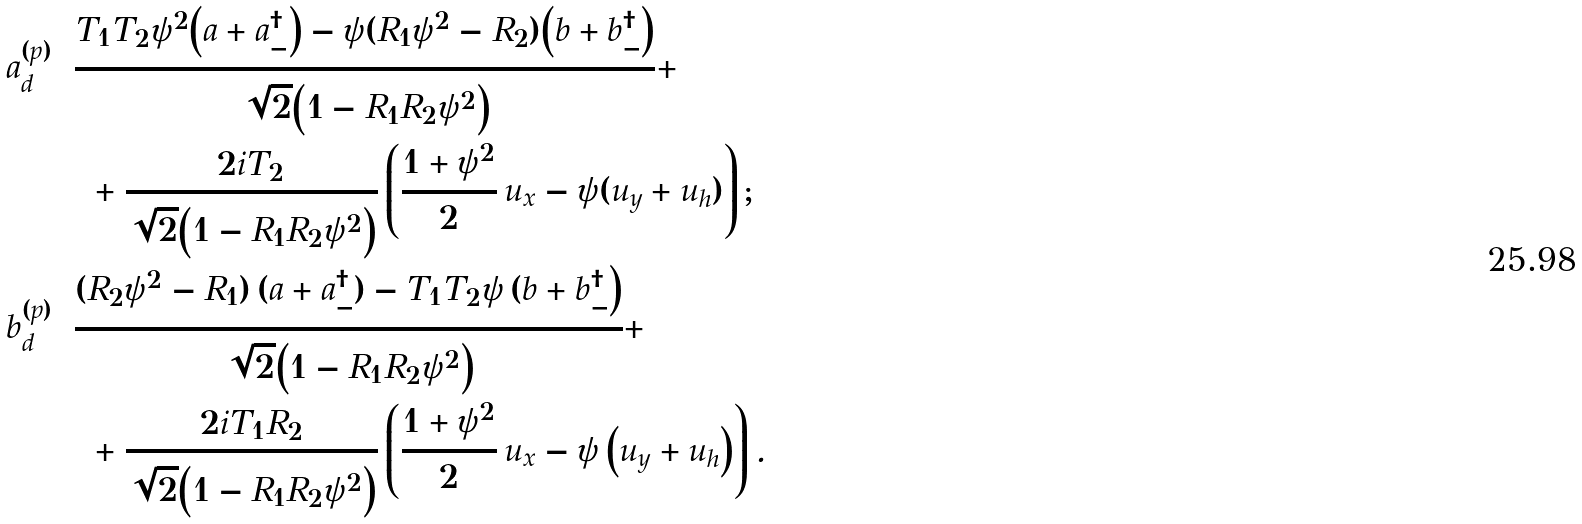Convert formula to latex. <formula><loc_0><loc_0><loc_500><loc_500>a _ { d } ^ { ( p ) } & = \frac { T _ { 1 } T _ { 2 } \psi ^ { 2 } \Big ( a + a ^ { \dag } _ { - } \Big ) - \psi ( R _ { 1 } \psi ^ { 2 } - R _ { 2 } ) \Big ( b + b _ { - } ^ { \dag } \Big ) } { \sqrt { 2 } \Big ( 1 - R _ { 1 } R _ { 2 } \psi ^ { 2 } \Big ) } + \\ & \quad + \frac { 2 i T _ { 2 } } { \sqrt { 2 } \Big ( 1 - R _ { 1 } R _ { 2 } \psi ^ { 2 } \Big ) } \left ( \frac { 1 + \psi ^ { 2 } } { 2 } \, u _ { x } - \psi ( u _ { y } + u _ { h } ) \right ) ; \\ b _ { d } ^ { ( p ) } & = \frac { ( R _ { 2 } \psi ^ { 2 } - R _ { 1 } ) \, ( a + a ^ { \dag } _ { - } ) - T _ { 1 } T _ { 2 } \psi \, ( b + b _ { - } ^ { \dag } \Big ) } { \sqrt { 2 } \Big ( 1 - R _ { 1 } R _ { 2 } \psi ^ { 2 } \Big ) } + \\ & \quad + \frac { 2 i T _ { 1 } R _ { 2 } } { \sqrt { 2 } \Big ( 1 - R _ { 1 } R _ { 2 } \psi ^ { 2 } \Big ) } \left ( \frac { 1 + \psi ^ { 2 } } { 2 } \, u _ { x } - \psi \, \Big ( u _ { y } + u _ { h } \Big ) \right ) .</formula> 